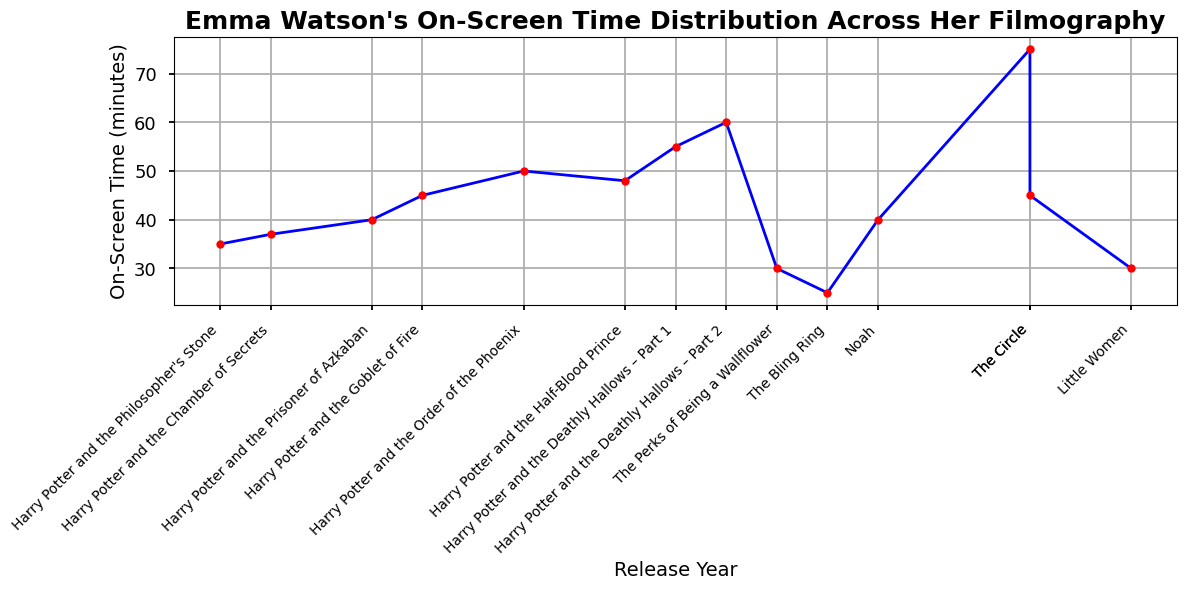Which film has the highest on-screen time for Emma Watson? The highest point on the line corresponds to "Beauty and the Beast" in 2017.
Answer: Beauty and the Beast How many films have an on-screen time of 40 minutes or more? Count the number of points on the line chart where the on-screen time is 40 minutes or more.
Answer: 7 Which Harry Potter film has the least on-screen time for Emma Watson? Look for the lowest point within the Harry Potter films, which is the first data set in the plot.
Answer: Philosopher's Stone What is the difference in on-screen time between "Harry Potter and the Philosopher's Stone" and "Harry Potter and the Deathly Hallows – Part 2"? Subtract the on-screen time of "Harry Potter and the Philosopher's Stone" (35 minutes) from that of "Harry Potter and the Deathly Hallows – Part 2" (60 minutes).
Answer: 25 minutes What is Emma Watson's average on-screen time in the Harry Potter series? Sum the on-screen times for all Harry Potter films and divide by the number of Harry Potter films (8).
Answer: 46.25 minutes What is the trend of Emma Watson's on-screen time across the Harry Potter series? Observe the line trend from 2001 to 2011 for the Harry Potter films. There is a general upward trend in on-screen time.
Answer: Increasing Which non-Harry Potter film has the highest on-screen time for Emma Watson? Exclude the Harry Potter films and check the highest point in the remaining data points.
Answer: Beauty and the Beast In which year did Emma Watson see her biggest increase in on-screen time compared to the previous film? Identify the largest positive difference between consecutive points on the x-axis in terms of release year.
Answer: 2017 What is the ratio of Emma Watson's on-screen time in "Beauty and the Beast" to that in "The Bling Ring"? Divide the on-screen time of "Beauty and the Beast" (75 minutes) by that of "The Bling Ring" (25 minutes).
Answer: 3 What is the median on-screen time for all listed films? Arrange the on-screen times in ascending order and find the middle value; if there is an even number of films, the median is the average of the two middle values.
Answer: 40 minutes 